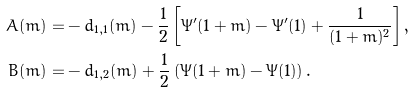<formula> <loc_0><loc_0><loc_500><loc_500>A ( m ) = & - d _ { 1 , 1 } ( m ) - \frac { 1 } { 2 } \left [ \Psi ^ { \prime } ( 1 + m ) - \Psi ^ { \prime } ( 1 ) + \frac { 1 } { ( 1 + m ) ^ { 2 } } \right ] , \\ B ( m ) = & - d _ { 1 , 2 } ( m ) + \frac { 1 } { 2 } \left ( \Psi ( 1 + m ) - \Psi ( 1 ) \right ) .</formula> 